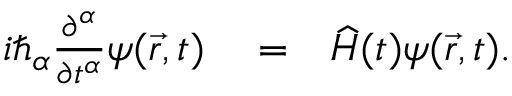<formula> <loc_0><loc_0><loc_500><loc_500>\begin{array} { r l r } { i \hbar { _ } { \alpha } \frac { \partial ^ { \alpha } } { \partial t ^ { \alpha } } \psi ( \vec { r } , t ) } & = } & { \widehat { H } ( t ) \psi ( \vec { r } , t ) . } \end{array}</formula> 